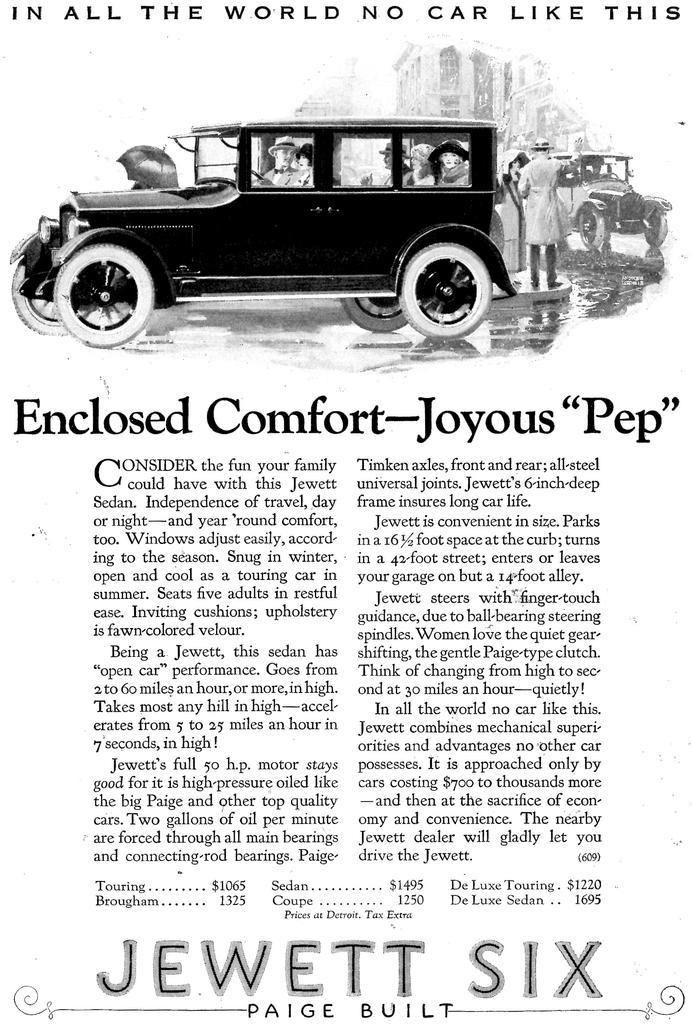Please provide a concise description of this image. In this image we can see an article and a picture of a car. 